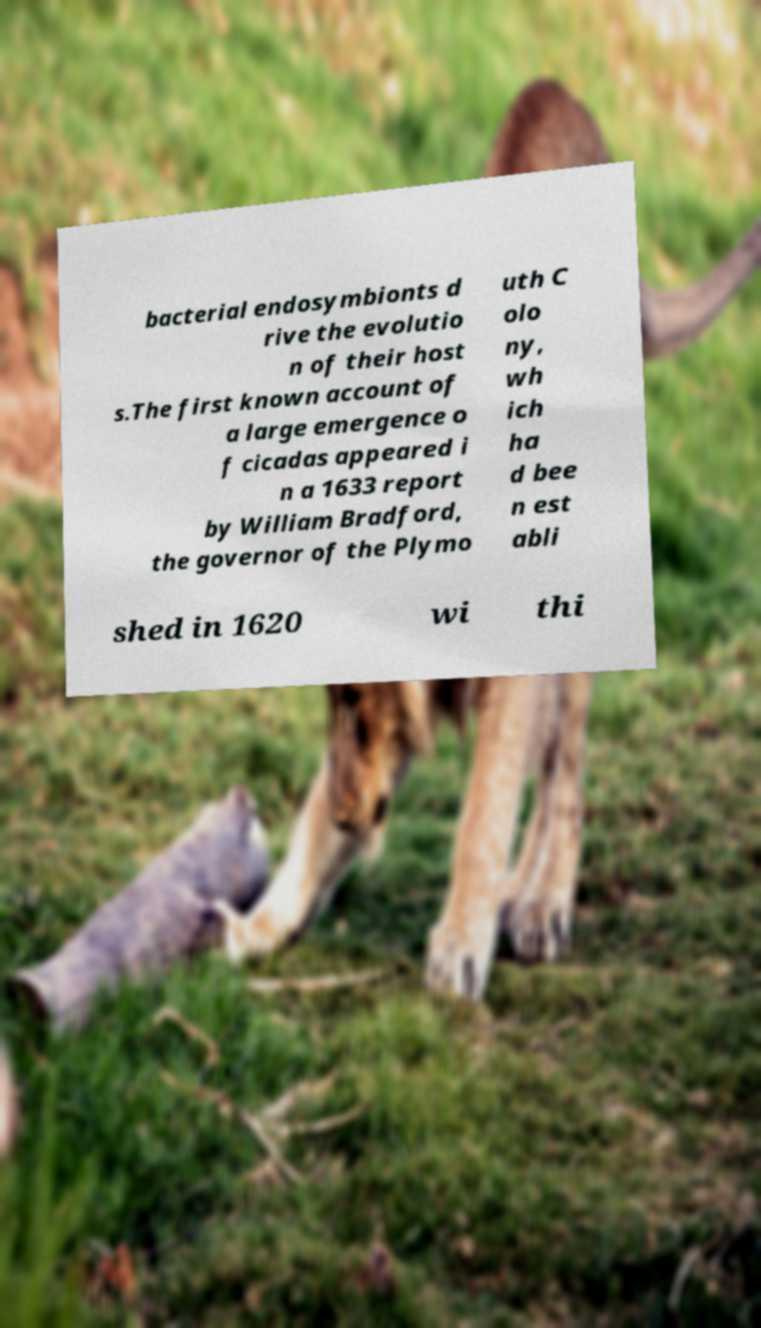Can you accurately transcribe the text from the provided image for me? bacterial endosymbionts d rive the evolutio n of their host s.The first known account of a large emergence o f cicadas appeared i n a 1633 report by William Bradford, the governor of the Plymo uth C olo ny, wh ich ha d bee n est abli shed in 1620 wi thi 